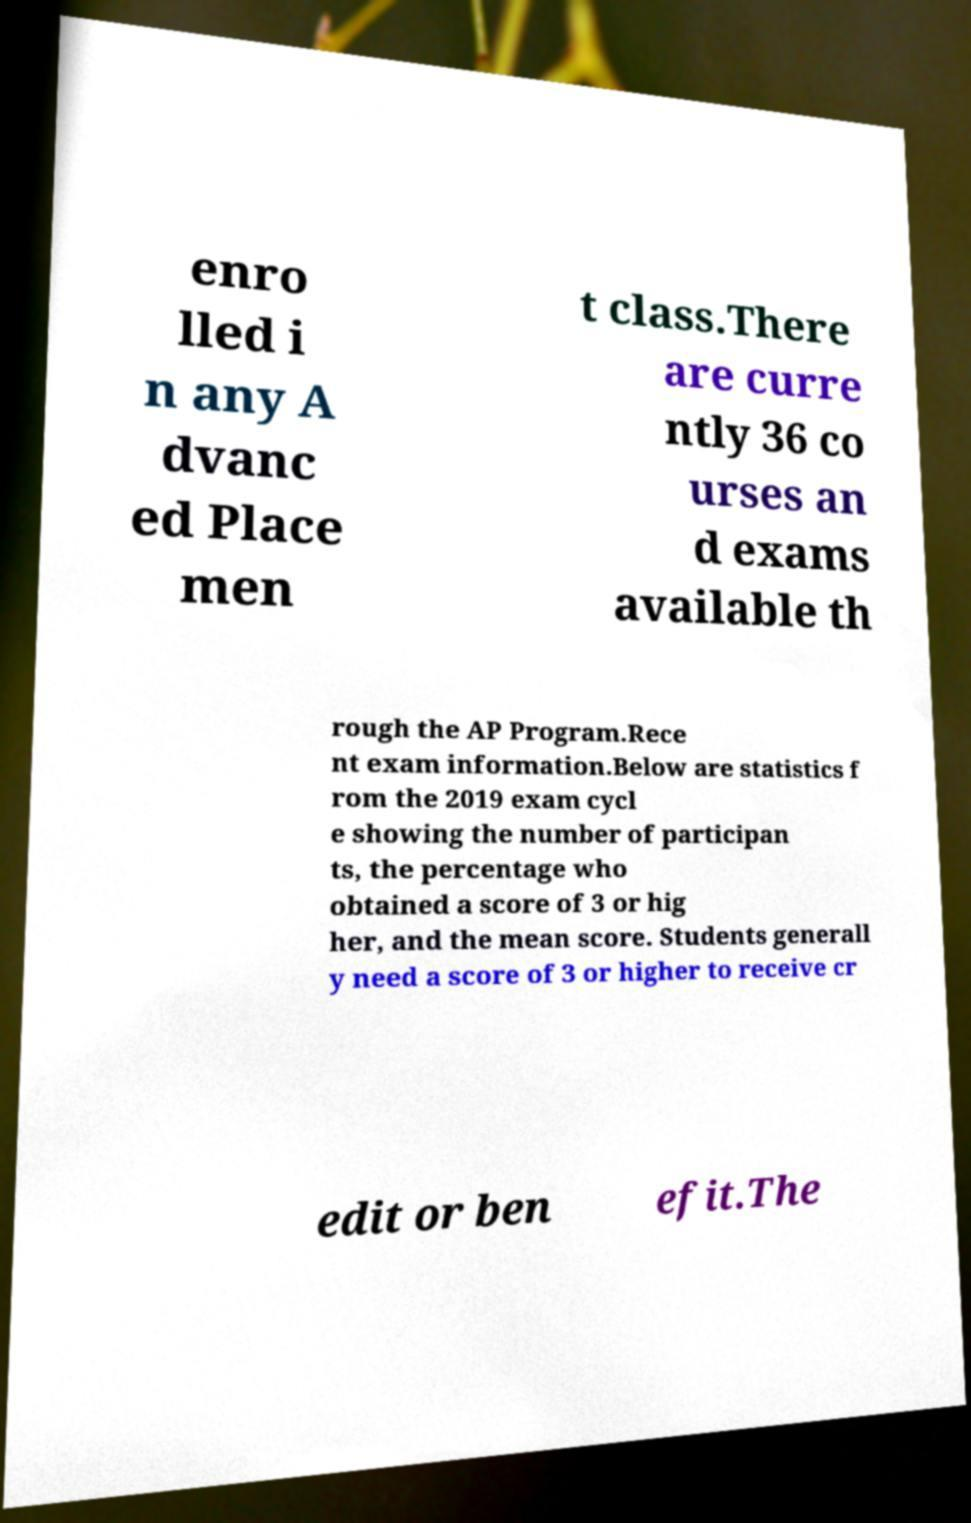Can you read and provide the text displayed in the image?This photo seems to have some interesting text. Can you extract and type it out for me? enro lled i n any A dvanc ed Place men t class.There are curre ntly 36 co urses an d exams available th rough the AP Program.Rece nt exam information.Below are statistics f rom the 2019 exam cycl e showing the number of participan ts, the percentage who obtained a score of 3 or hig her, and the mean score. Students generall y need a score of 3 or higher to receive cr edit or ben efit.The 